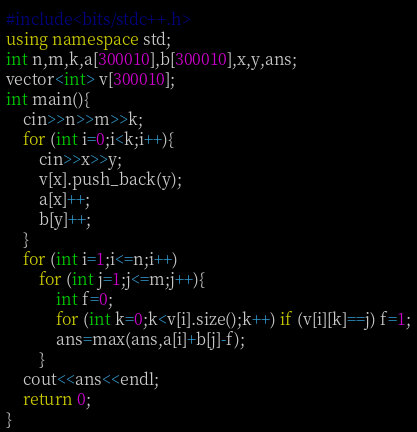<code> <loc_0><loc_0><loc_500><loc_500><_C++_>#include<bits/stdc++.h>
using namespace std;
int n,m,k,a[300010],b[300010],x,y,ans;
vector<int> v[300010];
int main(){
	cin>>n>>m>>k;
	for (int i=0;i<k;i++){
		cin>>x>>y;
		v[x].push_back(y);
		a[x]++;
		b[y]++;
	}
	for (int i=1;i<=n;i++)
		for (int j=1;j<=m;j++){
			int f=0;
			for (int k=0;k<v[i].size();k++) if (v[i][k]==j) f=1;
			ans=max(ans,a[i]+b[j]-f);
		}
	cout<<ans<<endl;
	return 0;
}</code> 